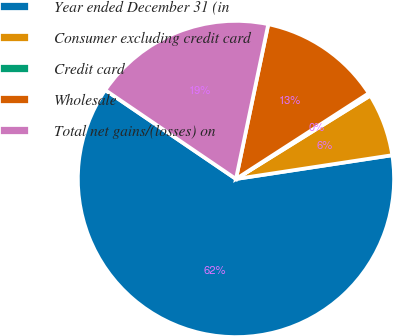Convert chart to OTSL. <chart><loc_0><loc_0><loc_500><loc_500><pie_chart><fcel>Year ended December 31 (in<fcel>Consumer excluding credit card<fcel>Credit card<fcel>Wholesale<fcel>Total net gains/(losses) on<nl><fcel>61.91%<fcel>6.44%<fcel>0.28%<fcel>12.6%<fcel>18.77%<nl></chart> 